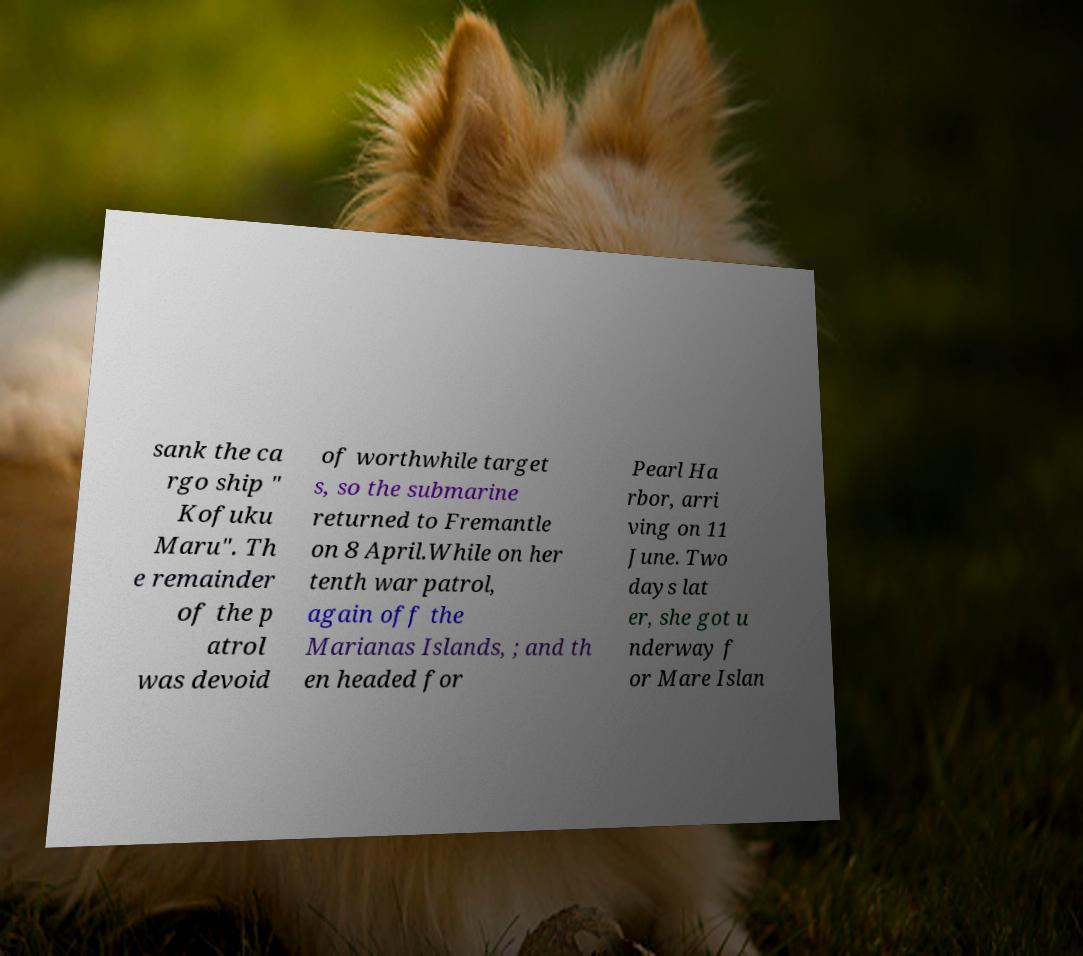There's text embedded in this image that I need extracted. Can you transcribe it verbatim? sank the ca rgo ship " Kofuku Maru". Th e remainder of the p atrol was devoid of worthwhile target s, so the submarine returned to Fremantle on 8 April.While on her tenth war patrol, again off the Marianas Islands, ; and th en headed for Pearl Ha rbor, arri ving on 11 June. Two days lat er, she got u nderway f or Mare Islan 